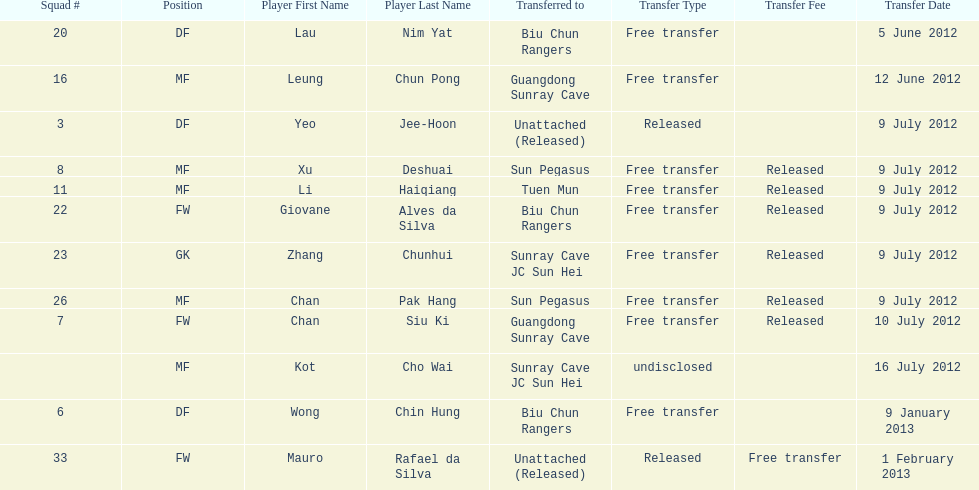Li haiqiang and xu deshuai both played which position? MF. Would you be able to parse every entry in this table? {'header': ['Squad #', 'Position', 'Player First Name', 'Player Last Name', 'Transferred to', 'Transfer Type', 'Transfer Fee', 'Transfer Date'], 'rows': [['20', 'DF', 'Lau', 'Nim Yat', 'Biu Chun Rangers', 'Free transfer', '', '5 June 2012'], ['16', 'MF', 'Leung', 'Chun Pong', 'Guangdong Sunray Cave', 'Free transfer', '', '12 June 2012'], ['3', 'DF', 'Yeo', 'Jee-Hoon', 'Unattached (Released)', 'Released', '', '9 July 2012'], ['8', 'MF', 'Xu', 'Deshuai', 'Sun Pegasus', 'Free transfer', 'Released', '9 July 2012'], ['11', 'MF', 'Li', 'Haiqiang', 'Tuen Mun', 'Free transfer', 'Released', '9 July 2012'], ['22', 'FW', 'Giovane', 'Alves da Silva', 'Biu Chun Rangers', 'Free transfer', 'Released', '9 July 2012'], ['23', 'GK', 'Zhang', 'Chunhui', 'Sunray Cave JC Sun Hei', 'Free transfer', 'Released', '9 July 2012'], ['26', 'MF', 'Chan', 'Pak Hang', 'Sun Pegasus', 'Free transfer', 'Released', '9 July 2012'], ['7', 'FW', 'Chan', 'Siu Ki', 'Guangdong Sunray Cave', 'Free transfer', 'Released', '10 July 2012'], ['', 'MF', 'Kot', 'Cho Wai', 'Sunray Cave JC Sun Hei', 'undisclosed', '', '16 July 2012'], ['6', 'DF', 'Wong', 'Chin Hung', 'Biu Chun Rangers', 'Free transfer', '', '9 January 2013'], ['33', 'FW', 'Mauro', 'Rafael da Silva', 'Unattached (Released)', 'Released', 'Free transfer', '1 February 2013']]} 